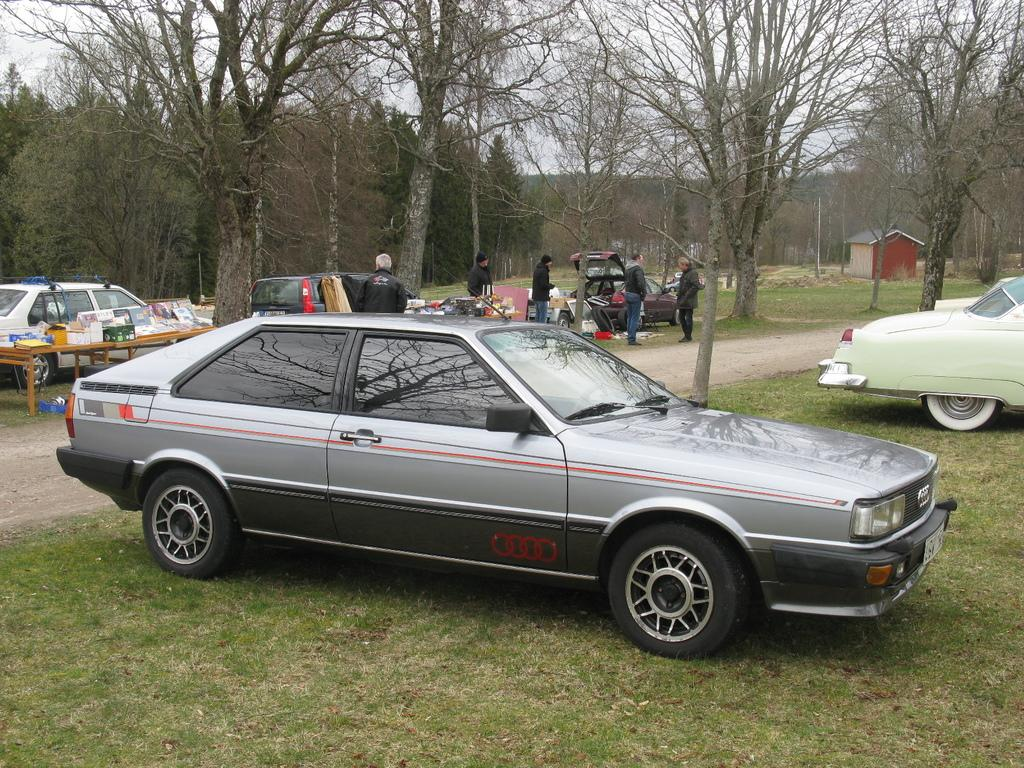Who or what can be seen in the image? There are people in the image. What else is present in the image besides people? There are vehicles, objects on tables, a booth, grass, trees, and the sky visible in the image. Can you describe the setting of the image? The image appears to be outdoors, given the presence of grass, trees, and the sky. What might the booth be used for? The booth could be used for various purposes, such as selling items or providing information. What is the rate of the shape in the image? There is no shape or rate mentioned in the image; it features people, vehicles, objects on tables, a booth, grass, trees, and the sky. 